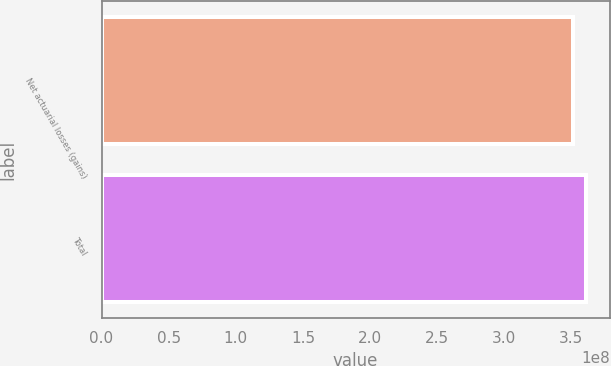<chart> <loc_0><loc_0><loc_500><loc_500><bar_chart><fcel>Net actuarial losses (gains)<fcel>Total<nl><fcel>3.51344e+08<fcel>3.60489e+08<nl></chart> 